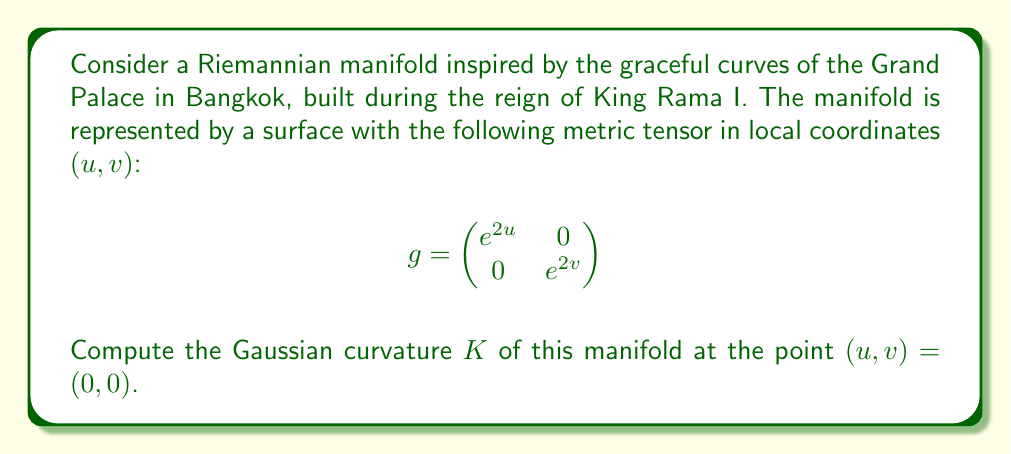Can you solve this math problem? To compute the Gaussian curvature of a Riemannian manifold, we'll follow these steps:

1) First, we need to calculate the Christoffel symbols. For a metric tensor $g_{ij}$, they are given by:

   $$\Gamma^k_{ij} = \frac{1}{2}g^{kl}\left(\frac{\partial g_{il}}{\partial x^j} + \frac{\partial g_{jl}}{\partial x^i} - \frac{\partial g_{ij}}{\partial x^l}\right)$$

2) For our metric, we have:
   $g_{11} = e^{2u}$, $g_{22} = e^{2v}$, $g_{12} = g_{21} = 0$
   $g^{11} = e^{-2u}$, $g^{22} = e^{-2v}$, $g^{12} = g^{21} = 0$

3) Calculating the non-zero Christoffel symbols:
   $$\Gamma^1_{11} = \frac{1}{2}g^{11}\frac{\partial g_{11}}{\partial u} = 1$$
   $$\Gamma^2_{22} = \frac{1}{2}g^{22}\frac{\partial g_{22}}{\partial v} = 1$$

4) The Riemann curvature tensor is given by:
   $$R^i_{jkl} = \frac{\partial \Gamma^i_{jl}}{\partial x^k} - \frac{\partial \Gamma^i_{jk}}{\partial x^l} + \Gamma^m_{jl}\Gamma^i_{mk} - \Gamma^m_{jk}\Gamma^i_{ml}$$

5) The only non-zero component is:
   $$R^1_{212} = -\frac{\partial \Gamma^1_{11}}{\partial v} = 0$$

6) The Gaussian curvature is given by:
   $$K = \frac{R_{1212}}{g_{11}g_{22} - g_{12}g_{21}} = \frac{g_{11}R^1_{212}}{g_{11}g_{22}} = 0$$

7) At the point $(u,v) = (0,0)$, the Gaussian curvature remains 0.
Answer: $K = 0$ 